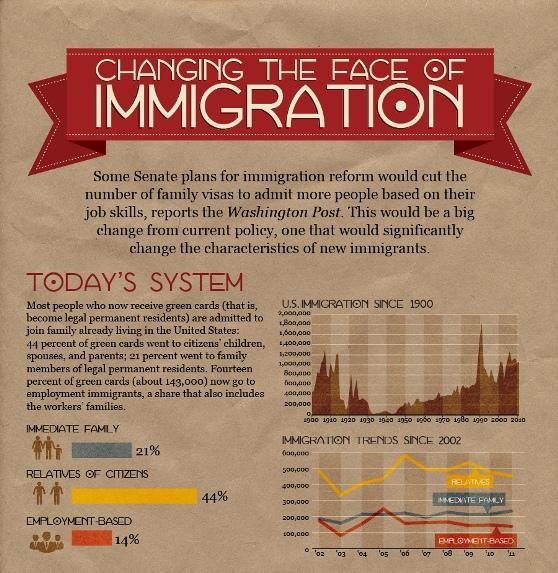In which year the lowest number of immediate family members moved to America?
Answer the question with a short phrase. 03 What is the color code for "Immediate Family"- red, grey, yellow, orange? grey In which year the highest number of U.S family relatives moved to America? 06 In which year the highest number of people moved to America for their job? 05 What is the color code for "Relatives"- red, green, yellow, orange? yellow What is the color code for "Employment-Based"- red, grey, orange, yellow? orange 